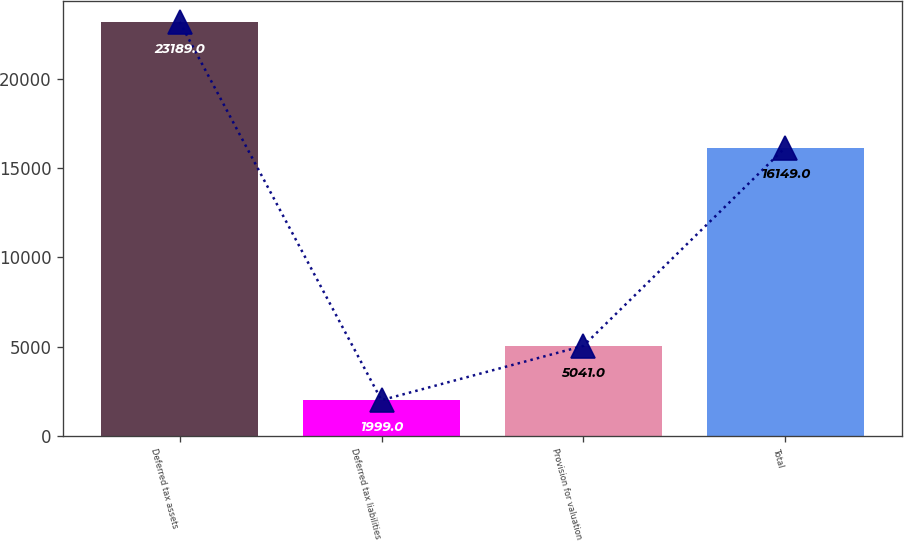Convert chart. <chart><loc_0><loc_0><loc_500><loc_500><bar_chart><fcel>Deferred tax assets<fcel>Deferred tax liabilities<fcel>Provision for valuation<fcel>Total<nl><fcel>23189<fcel>1999<fcel>5041<fcel>16149<nl></chart> 